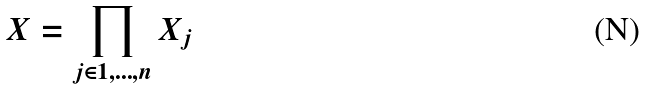Convert formula to latex. <formula><loc_0><loc_0><loc_500><loc_500>X = \prod _ { j \in 1 , \dots , n } X _ { j }</formula> 